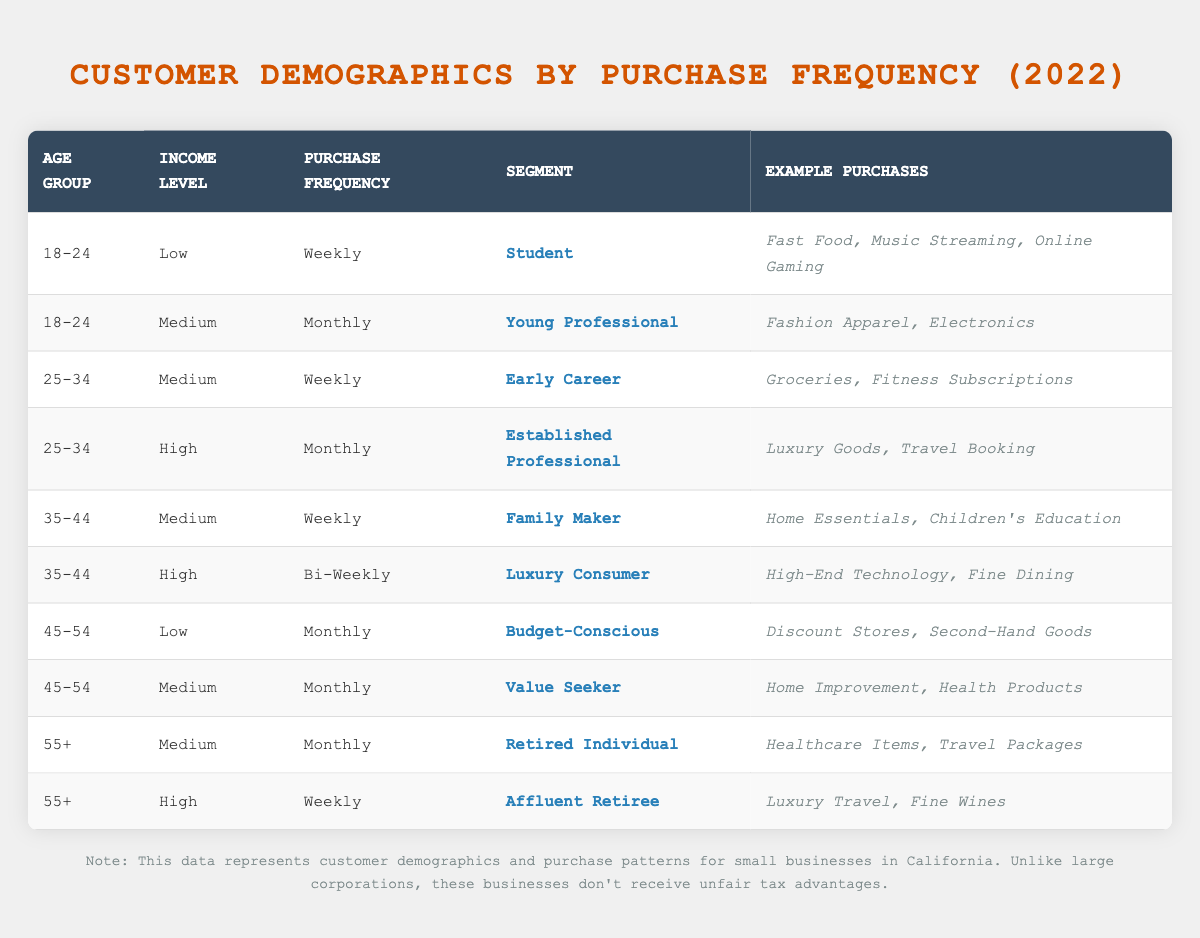What is the purchase frequency for the "Affluent Retiree" segment? According to the table, the "Affluent Retiree" segment falls in the age group "55+" and has a purchase frequency of "Weekly."
Answer: Weekly How many segments have a purchase frequency of "Monthly"? By reviewing the table, the segments with a monthly purchase frequency are "Young Professional," "Established Professional," "Budget-Conscious," "Value Seeker," and "Retired Individual," totaling five segments.
Answer: 5 Is there a segment in the "45-54" age group that has a purchase frequency of "Weekly"? Looking at the table, the "45-54" age group does not include any segment with a "Weekly" purchase frequency; the relevant segments are "Budget-Conscious" and "Value Seeker," both with "Monthly" frequency.
Answer: No Which income level has the most "Weekly" purchase frequencies? Upon examining the table, the "Medium" income level has the segments "Early Career," "Family Maker," and "Affluent Retiree," making a total of three segments, while the "High" income level has one segment ("Affluent Retiree"). Therefore, "Medium" is the most frequent.
Answer: Medium What is the average number of purchase frequencies per age group? The age groups "18-24," "25-34," "35-44," "45-54," and "55+" have frequencies of Weekly, Monthly, Weekly, Monthly, and Monthly respectively, giving a total of 10 occurrences. Dividing by the number of age groups (5) gives an average of 2.
Answer: 2 Are there any "High" income level segments that purchase weekly? In the table, the "Affluent Retiree" segment is the only "High" income level segment that purchases weekly, while "Luxury Consumer" has a "Bi-Weekly" frequency. Therefore, there is one.
Answer: Yes Which segment has the highest income level and what is its purchase frequency? The table shows the "Affluent Retiree" segment as the highest income level with a "Weekly" purchase frequency.
Answer: Affluent Retiree, Weekly How many unique purchase frequencies are presented in the table? The purchase frequencies listed are "Weekly," "Monthly," and "Bi-Weekly." Since "Weekly" and "Monthly" both appear multiple times while "Bi-Weekly" only appears once, there are a total of three unique purchase frequencies in the table.
Answer: 3 